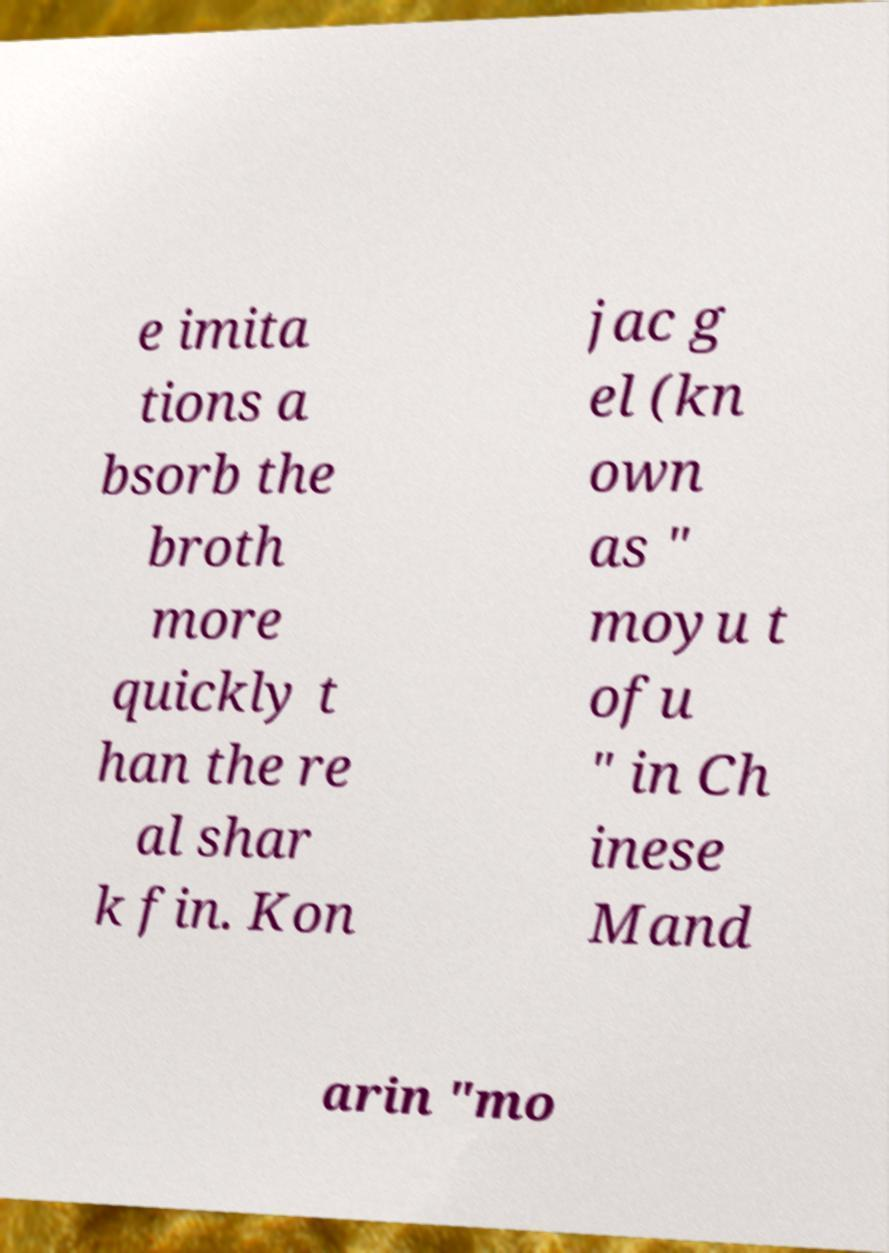Can you read and provide the text displayed in the image?This photo seems to have some interesting text. Can you extract and type it out for me? e imita tions a bsorb the broth more quickly t han the re al shar k fin. Kon jac g el (kn own as " moyu t ofu " in Ch inese Mand arin "mo 